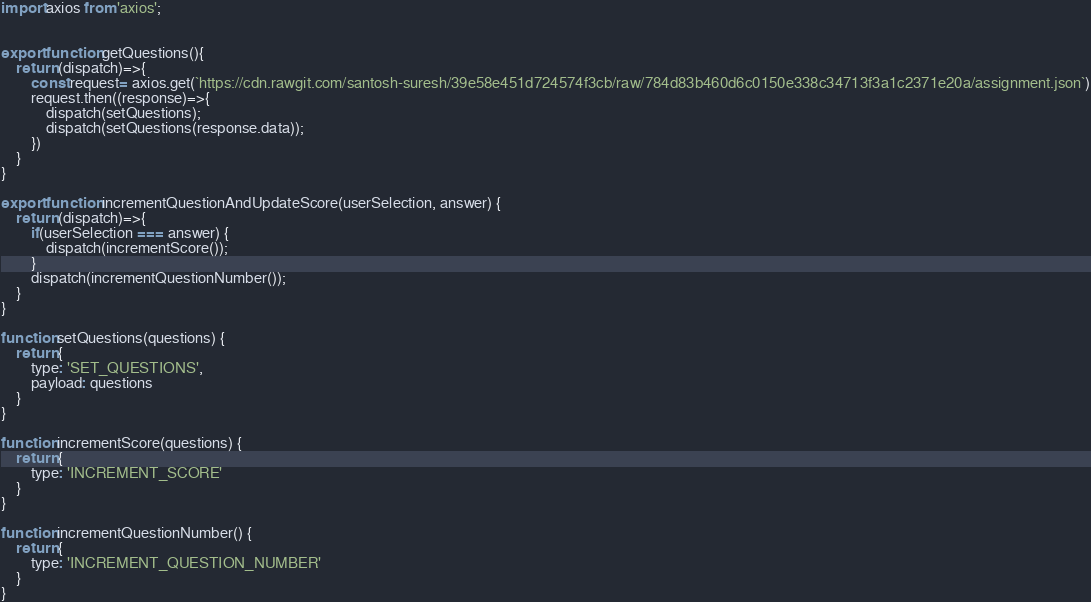<code> <loc_0><loc_0><loc_500><loc_500><_JavaScript_>import axios from 'axios';


export function getQuestions(){
	return (dispatch)=>{
		const request= axios.get(`https://cdn.rawgit.com/santosh-suresh/39e58e451d724574f3cb/raw/784d83b460d6c0150e338c34713f3a1c2371e20a/assignment.json`)
		request.then((response)=>{
            dispatch(setQuestions);
            dispatch(setQuestions(response.data));
		})
    }
}

export function incrementQuestionAndUpdateScore(userSelection, answer) {
    return (dispatch)=>{
        if(userSelection === answer) {
            dispatch(incrementScore());
        }
        dispatch(incrementQuestionNumber());
    }
}

function setQuestions(questions) {
    return {
        type: 'SET_QUESTIONS',
        payload: questions
    }
}

function incrementScore(questions) {
    return {
        type: 'INCREMENT_SCORE'
    }
}

function incrementQuestionNumber() {
    return {
        type: 'INCREMENT_QUESTION_NUMBER'
    }
}</code> 